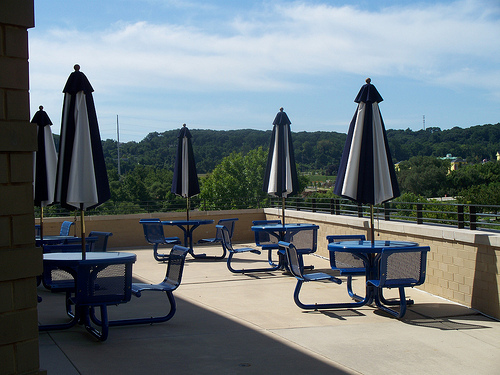<image>
Is the parasol on the table? Yes. Looking at the image, I can see the parasol is positioned on top of the table, with the table providing support. 